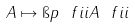Convert formula to latex. <formula><loc_0><loc_0><loc_500><loc_500>A \mapsto \i p { \ f i i } { A \ f i i }</formula> 